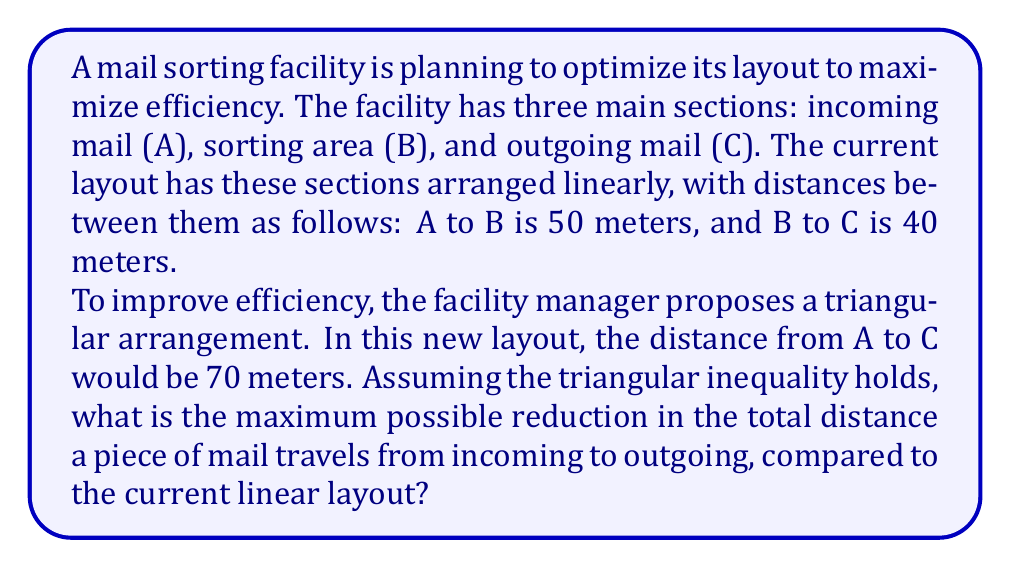Solve this math problem. Let's approach this step-by-step:

1) In the current linear layout:
   Total distance = AB + BC = 50 + 40 = 90 meters

2) In the proposed triangular layout:
   We know AC = 70 meters, and we need to find the new AB and BC distances.

3) Let's denote the new AB distance as x and the new BC distance as y.

4) From the triangle inequality theorem, we know:
   $$x + y > 70$$
   $$x + 70 > y$$
   $$y + 70 > x$$

5) To minimize the total distance (x + y), we need to find the smallest possible values for x and y that satisfy these inequalities.

6) The optimal solution occurs when the triangle is as "flat" as possible, i.e., when:
   $$x + y = 70$$

7) Substituting this into the other inequalities:
   $$x + 70 > 70 - x$$
   $$2x > 0$$
   $$x > 0$$

   Similarly for y:
   $$y > 0$$

8) The smallest positive values that satisfy x + y = 70 are:
   $$x = 35$$ and $$y = 35$$

9) Therefore, in the optimized triangular layout:
   Total distance = AB + BC = 35 + 35 = 70 meters

10) The reduction in distance is:
    $$90 - 70 = 20$$ meters

11) To express this as a percentage:
    $$\frac{20}{90} \times 100\% = 22.22\%$$
Answer: The maximum possible reduction in the total distance a piece of mail travels is 20 meters, or approximately 22.22%. 